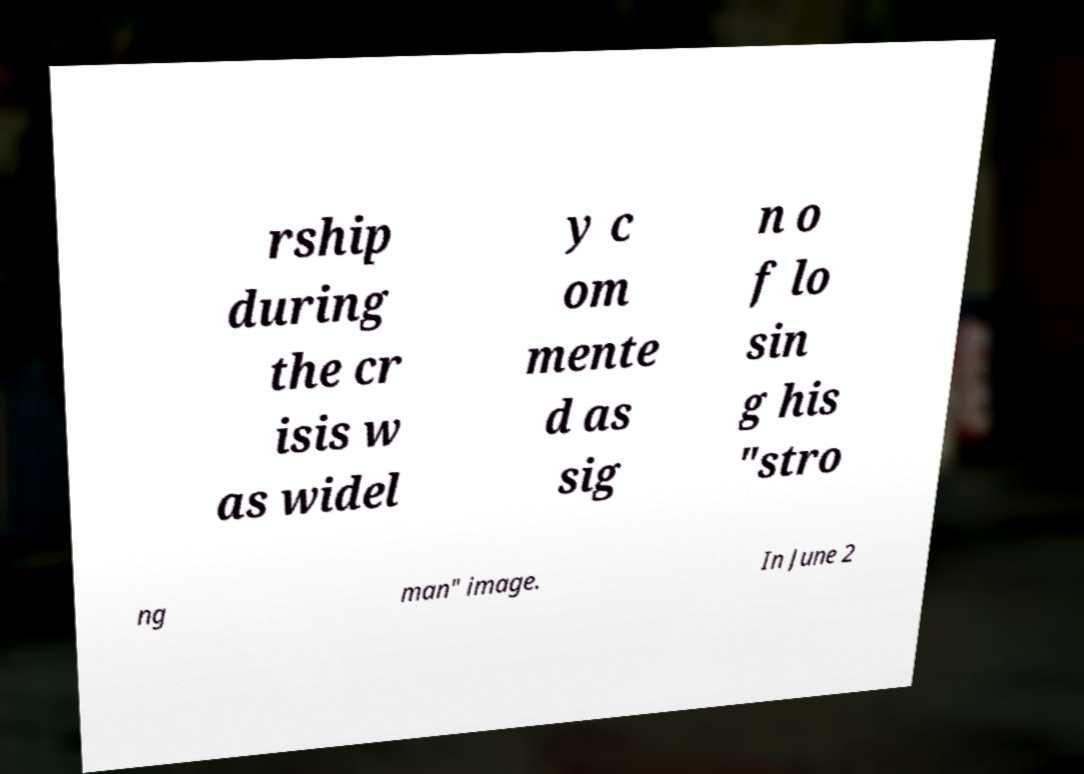Could you assist in decoding the text presented in this image and type it out clearly? rship during the cr isis w as widel y c om mente d as sig n o f lo sin g his "stro ng man" image. In June 2 